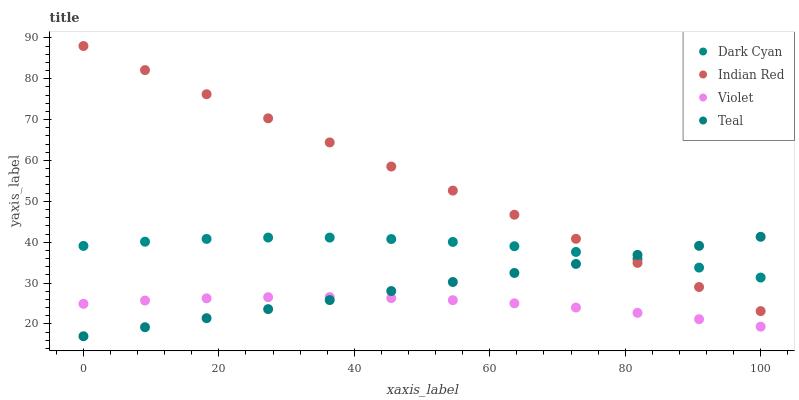Does Violet have the minimum area under the curve?
Answer yes or no. Yes. Does Indian Red have the maximum area under the curve?
Answer yes or no. Yes. Does Teal have the minimum area under the curve?
Answer yes or no. No. Does Teal have the maximum area under the curve?
Answer yes or no. No. Is Indian Red the smoothest?
Answer yes or no. Yes. Is Dark Cyan the roughest?
Answer yes or no. Yes. Is Teal the smoothest?
Answer yes or no. No. Is Teal the roughest?
Answer yes or no. No. Does Teal have the lowest value?
Answer yes or no. Yes. Does Indian Red have the lowest value?
Answer yes or no. No. Does Indian Red have the highest value?
Answer yes or no. Yes. Does Teal have the highest value?
Answer yes or no. No. Is Violet less than Dark Cyan?
Answer yes or no. Yes. Is Indian Red greater than Violet?
Answer yes or no. Yes. Does Dark Cyan intersect Teal?
Answer yes or no. Yes. Is Dark Cyan less than Teal?
Answer yes or no. No. Is Dark Cyan greater than Teal?
Answer yes or no. No. Does Violet intersect Dark Cyan?
Answer yes or no. No. 